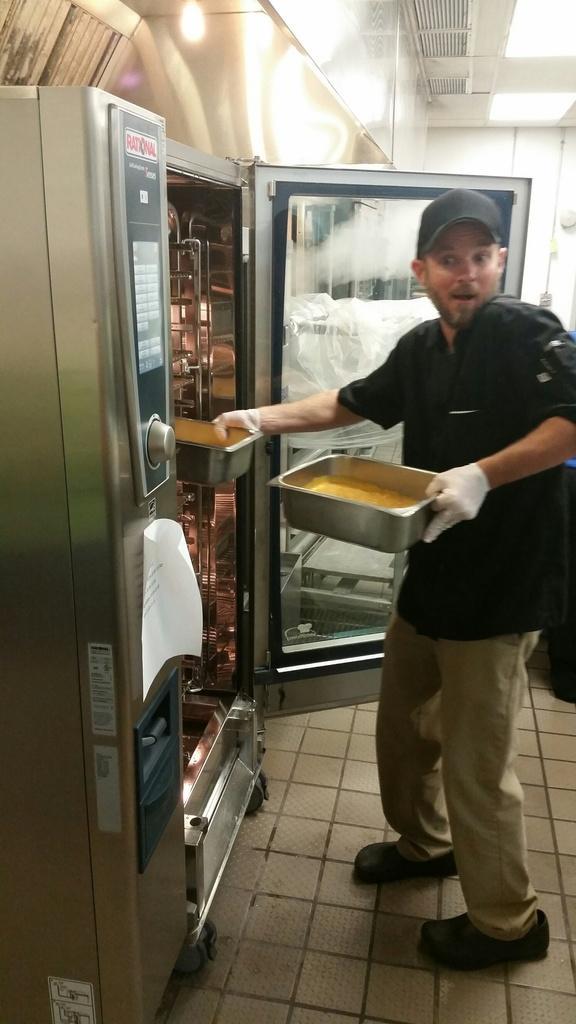Can you describe this image briefly? In the middle a man is standing and placing the vessels in this machine, he wore black color t-shirt, cap. 